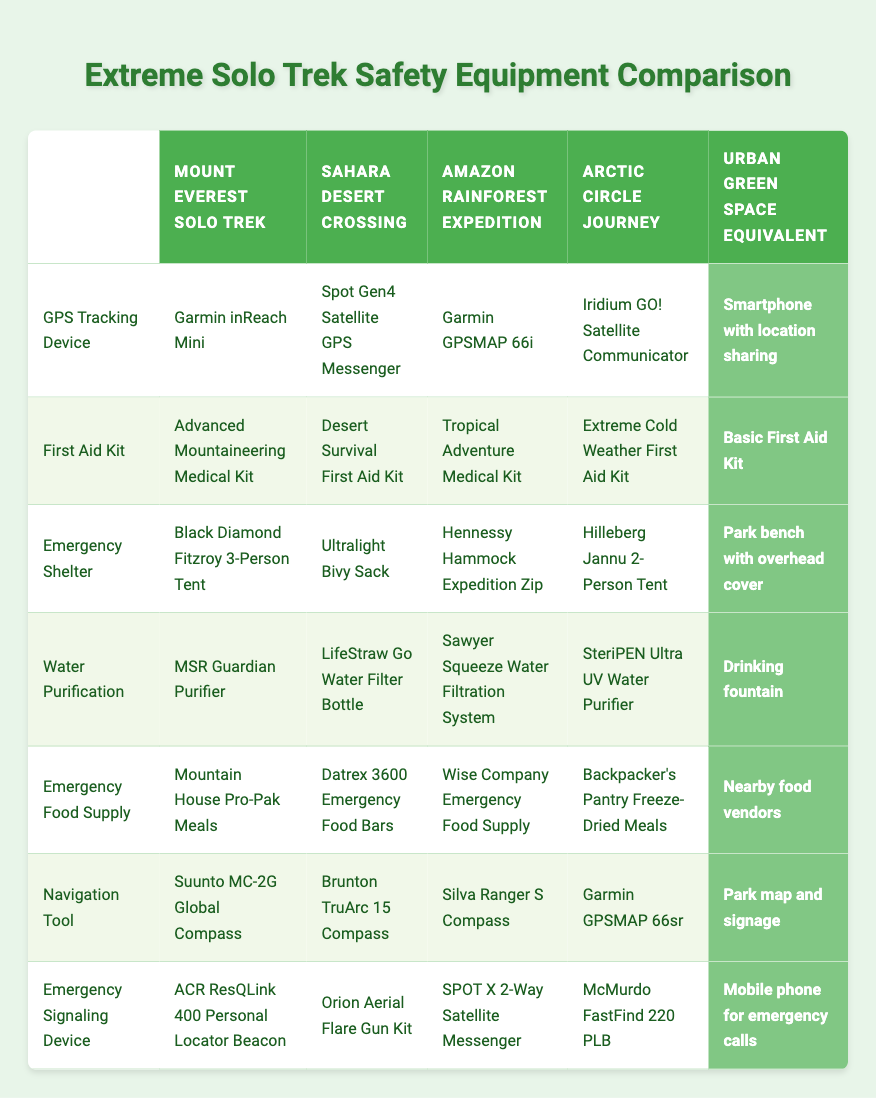What GPS tracking device is used for the Sahara Desert Crossing? The table indicates that the GPS tracking device used for the Sahara Desert Crossing is the Spot Gen4 Satellite GPS Messenger.
Answer: Spot Gen4 Satellite GPS Messenger Which expedition has the most sophisticated first aid kit? To determine this, we can look at the first aid kit for each expedition. The Mount Everest Solo Trek has an Advanced Mountaineering Medical Kit, which implies a higher level of sophistication compared to the other options.
Answer: Mount Everest Solo Trek How many unique types of emergency shelters are listed in the table? There are four different expeditions listed, and each has a unique type of emergency shelter, specifically: Black Diamond Fitzroy 3-Person Tent, Ultralight Bivy Sack, Hennessy Hammock Expedition Zip, and Hilleberg Jannu 2-Person Tent. Since they are all distinct, we can count them as four unique types.
Answer: Four Is there any emergency signaling device available for the Urban Green Space Equivalent? The table lists that the Urban Green Space Equivalent uses a mobile phone for emergency calls, which functions as an emergency signaling device. Thus, the answer is yes.
Answer: Yes For water purification, which trek has the lightest equipment? In the table, we can see four different devices used for water purification in the treks. The LifeStraw Go Water Filter Bottle is commonly regarded as a lightweight option for such activities, therefore it can be considered the lightest among those listed.
Answer: Sahara Desert Crossing What is the difference in the type of emergency food supply between the Mount Everest Solo Trek and the Amazon Rainforest Expedition? Looking at the table, the Mount Everest Solo Trek uses Mountain House Pro-Pak Meals, while the Amazon Rainforest Expedition utilizes Wise Company Emergency Food Supply. Thus, the difference lies in both the brand and style of food supply, where one is a freeze-dried meal and the other offers a variety of emergency food items.
Answer: Different brands and types Can you find any similarity in the navigation tools used for extreme treks and urban green spaces? The navigation tools listed for the extreme treks include compasses and GPS devices. The Urban Green Space Equivalent uses a park map and signage which serves a similar purpose for navigation, indicating a common goal of aiding orientation in their respective environments.
Answer: Yes Which safety equipment is consistent across all extreme treks? Analyzing the safety equipment listed, none of the specific items like GPS, first aid kits, emergency shelters, or food supplies appear consistently across all the expeditions; they each have unique entries. Thus, the answer is that there is no safety equipment consistent across all treks.
Answer: No 